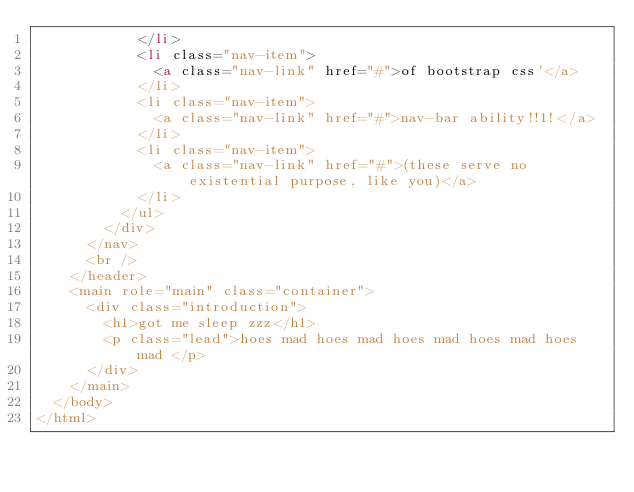Convert code to text. <code><loc_0><loc_0><loc_500><loc_500><_HTML_>            </li>
            <li class="nav-item">
              <a class="nav-link" href="#">of bootstrap css'</a>
            </li>
            <li class="nav-item">
              <a class="nav-link" href="#">nav-bar ability!!1!</a>
            </li>
            <li class="nav-item">
              <a class="nav-link" href="#">(these serve no existential purpose, like you)</a>
            </li>
          </ul>
        </div>
      </nav>
      <br />
    </header>
    <main role="main" class="container">
      <div class="introduction">
        <h1>got me sleep zzz</h1>
        <p class="lead">hoes mad hoes mad hoes mad hoes mad hoes mad </p>
      </div>
    </main>
  </body>
</html>
</code> 